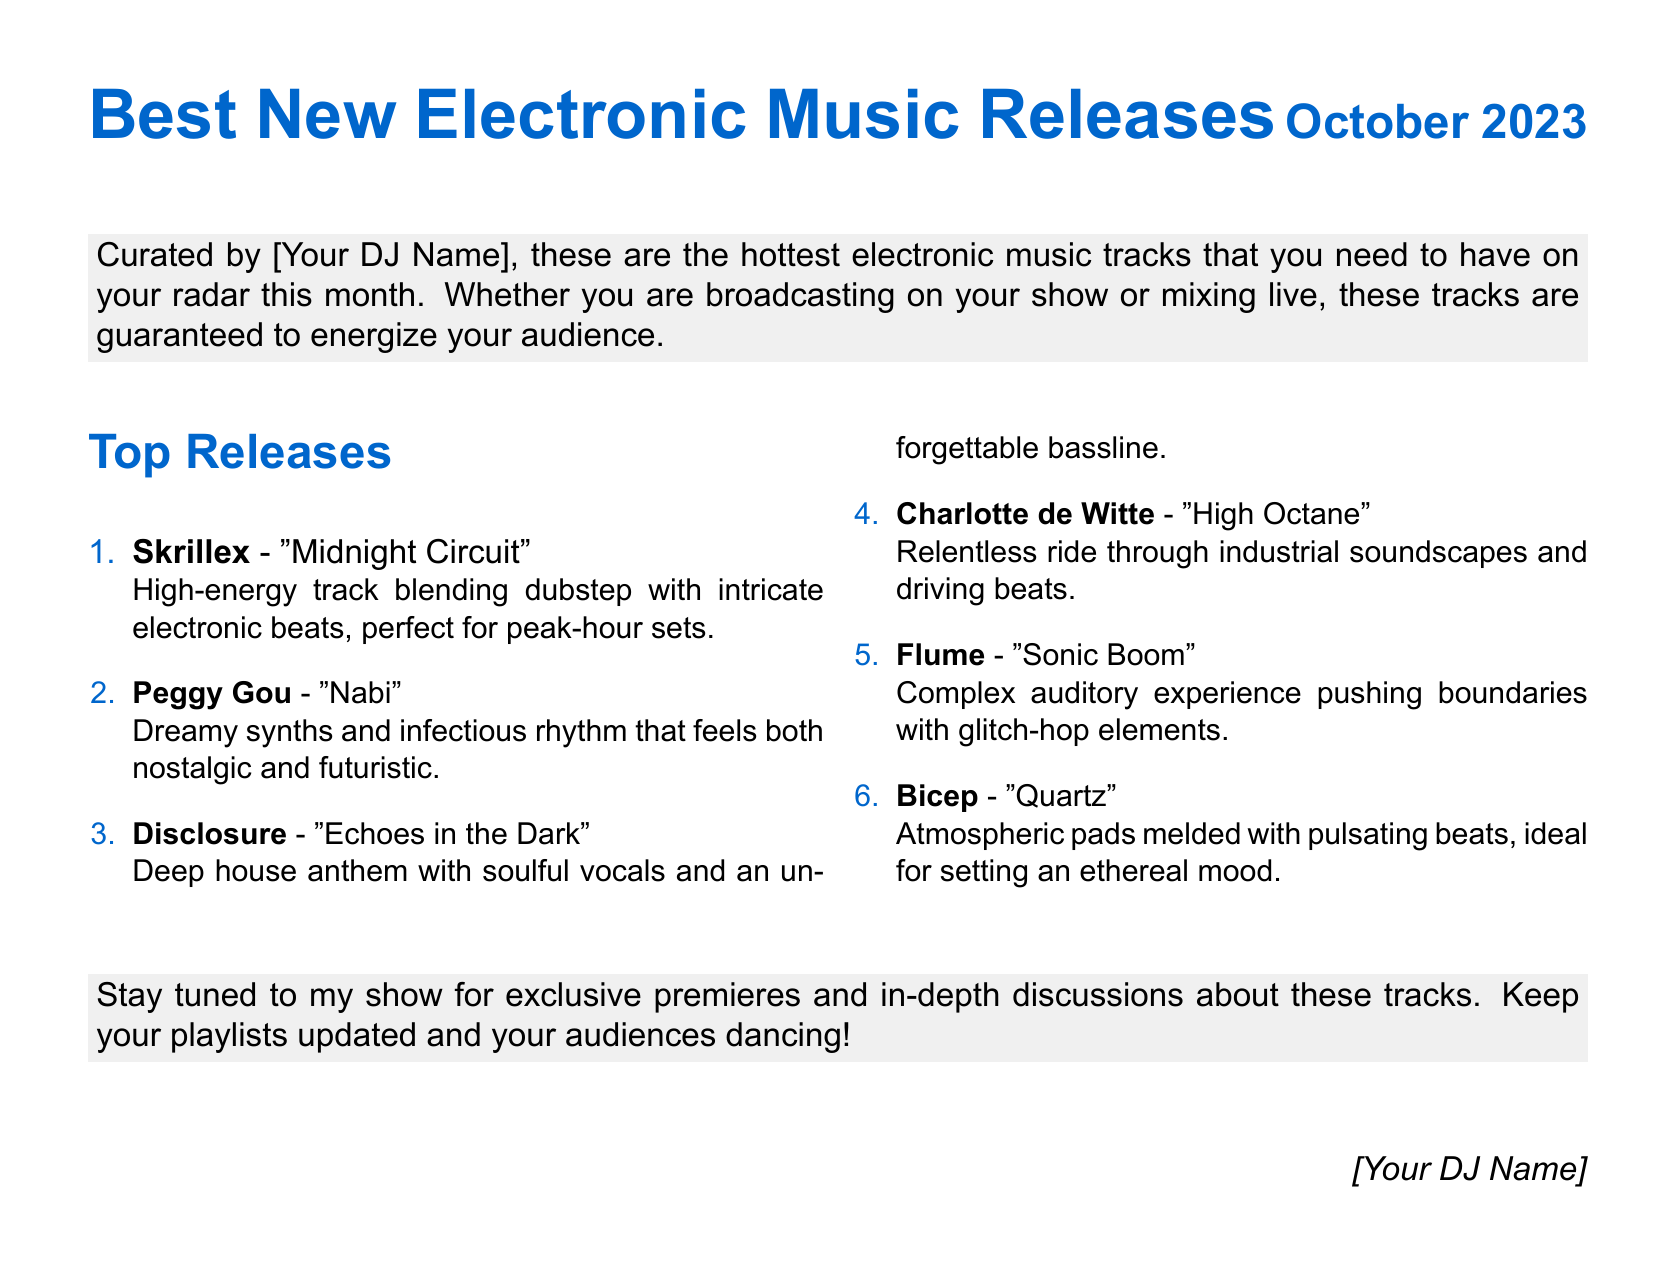What is the title of Peggy Gou's track? The title of Peggy Gou's track is mentioned in the list of top releases in the document.
Answer: "Nabi" How many tracks are listed under Top Releases? The document specifies the number of tracks listed in the Top Releases section.
Answer: 6 Which artist released the track "High Octane"? The artist associated with the track "High Octane" is directly stated in the document.
Answer: Charlotte de Witte What genre does Skrillex's "Midnight Circuit" blend with? The genre blend for Skrillex's track is described in the track highlights provided in the document.
Answer: Dubstep What type of experience does Flume's "Sonic Boom" offer? The experience offered by Flume's track is described using specific terminology in the document.
Answer: Complex auditory experience Which track is described as an anthem with soulful vocals? The track described with these characteristics is explicitly listed in the Top Releases section.
Answer: "Echoes in the Dark" What kind of soundscapes does Charlotte de Witte's track feature? The type of soundscapes in Charlotte de Witte's track is clearly mentioned in the highlights.
Answer: Industrial soundscapes What color theme is used for the document's title? The color theme for the title can be discerned from the formatting specified in the document.
Answer: DJ blue 